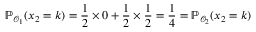<formula> <loc_0><loc_0><loc_500><loc_500>\mathbb { P } _ { \mathcal { O } _ { 1 } } ( x _ { 2 } = k ) = \frac { 1 } { 2 } \times 0 + \frac { 1 } { 2 } \times \frac { 1 } { 2 } = \frac { 1 } { 4 } = \mathbb { P } _ { \mathcal { O } _ { 2 } } ( x _ { 2 } = k )</formula> 